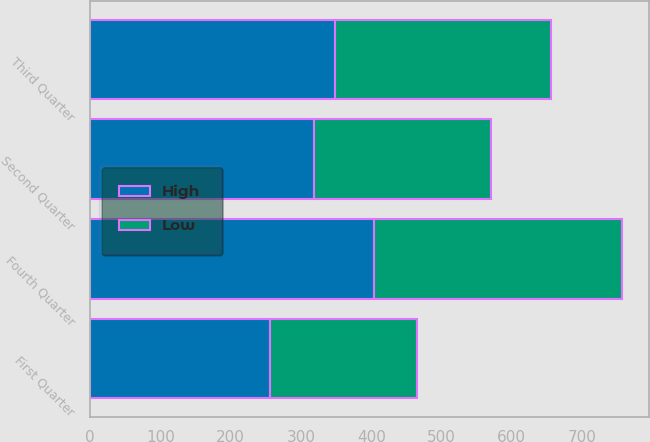Convert chart. <chart><loc_0><loc_0><loc_500><loc_500><stacked_bar_chart><ecel><fcel>First Quarter<fcel>Second Quarter<fcel>Third Quarter<fcel>Fourth Quarter<nl><fcel>High<fcel>255.77<fcel>318.05<fcel>348.79<fcel>403.7<nl><fcel>Low<fcel>209.83<fcel>253.11<fcel>307.22<fcel>353.49<nl></chart> 